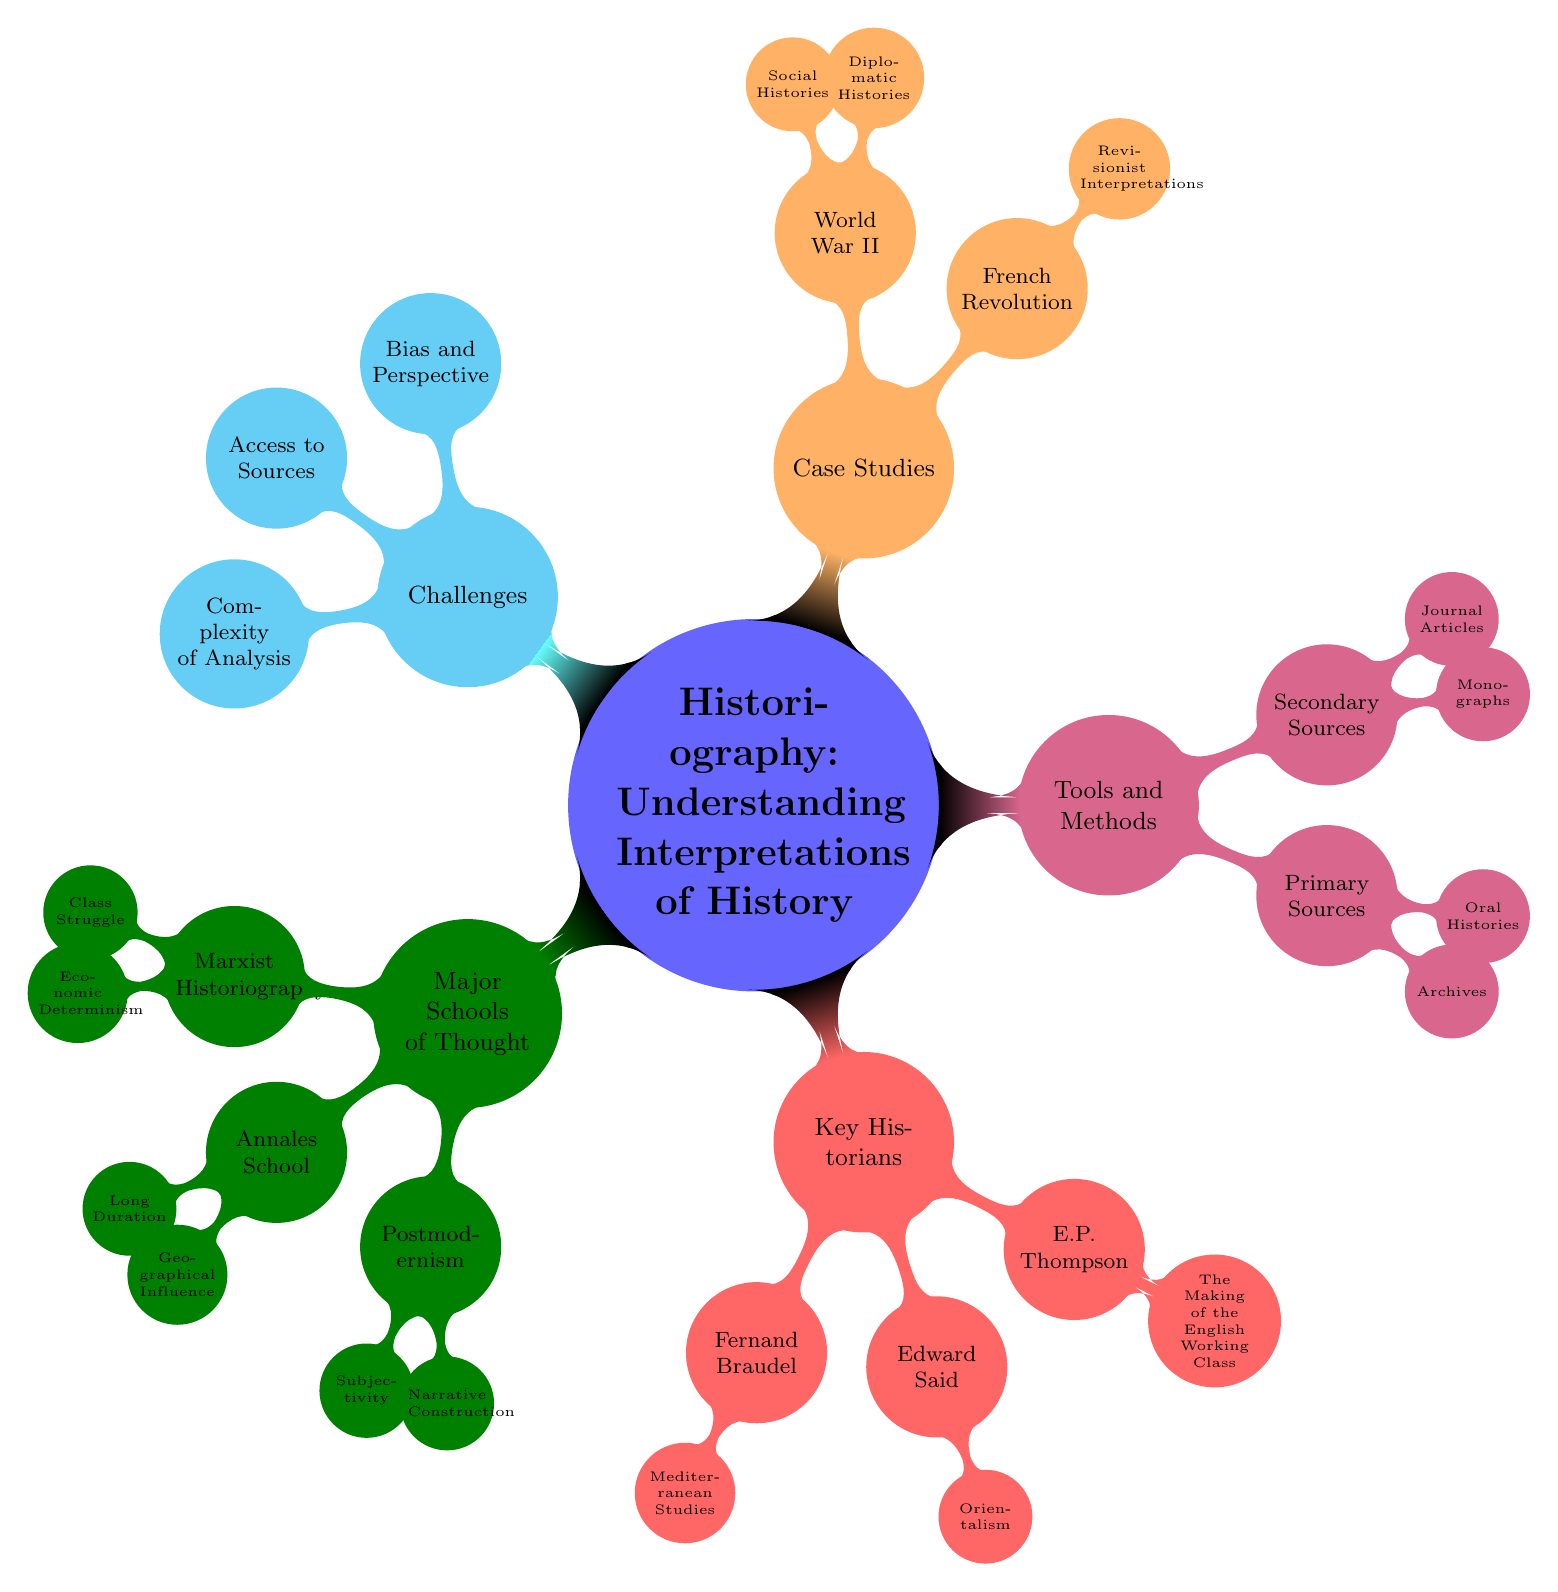What are the three major schools of thought in historiography? In the diagram, the major schools of thought are listed under the "Major Schools of Thought" node. They are "Marxist Historiography," "Annales School," and "Postmodernism."
Answer: Marxist Historiography, Annales School, Postmodernism How many key historians are highlighted in the diagram? Under the "Key Historians" node, three historians are mentioned: Fernand Braudel, Edward Said, and E.P. Thompson.
Answer: 3 What is one subnode associated with Marxist Historiography? The diagram shows two subnodes connected to "Marxist Historiography." One of these subnodes is "Class Struggle," which directly describes a concept within that historiographical approach.
Answer: Class Struggle Which case study is related to revisionist interpretations? The diagram indicates that "Revisionist Interpretations" is a subnode under the "French Revolution" case study category. This suggests a more nuanced view of the French Revolution in historiography.
Answer: French Revolution What challenges are listed in the diagram regarding historiographical analysis? In the "Challenges" section of the diagram, three challenges are highlighted: "Bias and Perspective," "Access to Sources," and "Complexity of Analysis." These represent difficulties faced in the study of historiography.
Answer: Bias and Perspective, Access to Sources, Complexity of Analysis What is one method for gathering primary sources in historiography? The "Tools and Methods" section includes a node for "Primary Sources," which contains subnodes. One of these subnodes is "Archives," pointing to a key method for collecting primary data in historical research.
Answer: Archives How does the Annales School approach historical duration? The diagram mentions "Long Duration" as a subnode of the "Annales School." This indicates the school's focus on long-term social and economic patterns rather than short-term events.
Answer: Long Duration What type of history is associated with Edward Said? The diagram relates Edward Said to the subnode "Orientalism," indicating his critical perspective on how the East has been represented in Western literature and history.
Answer: Orientalism 